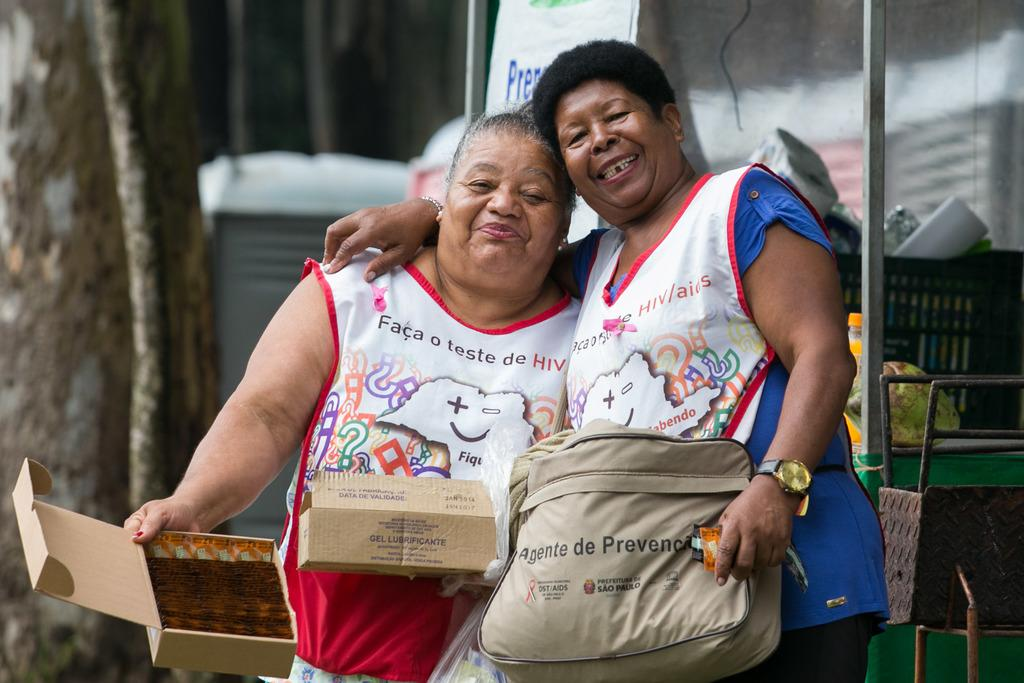Provide a one-sentence caption for the provided image. a pair of women taking a picture together with one wearing an apron that says 'faca o teste de HIV'. 